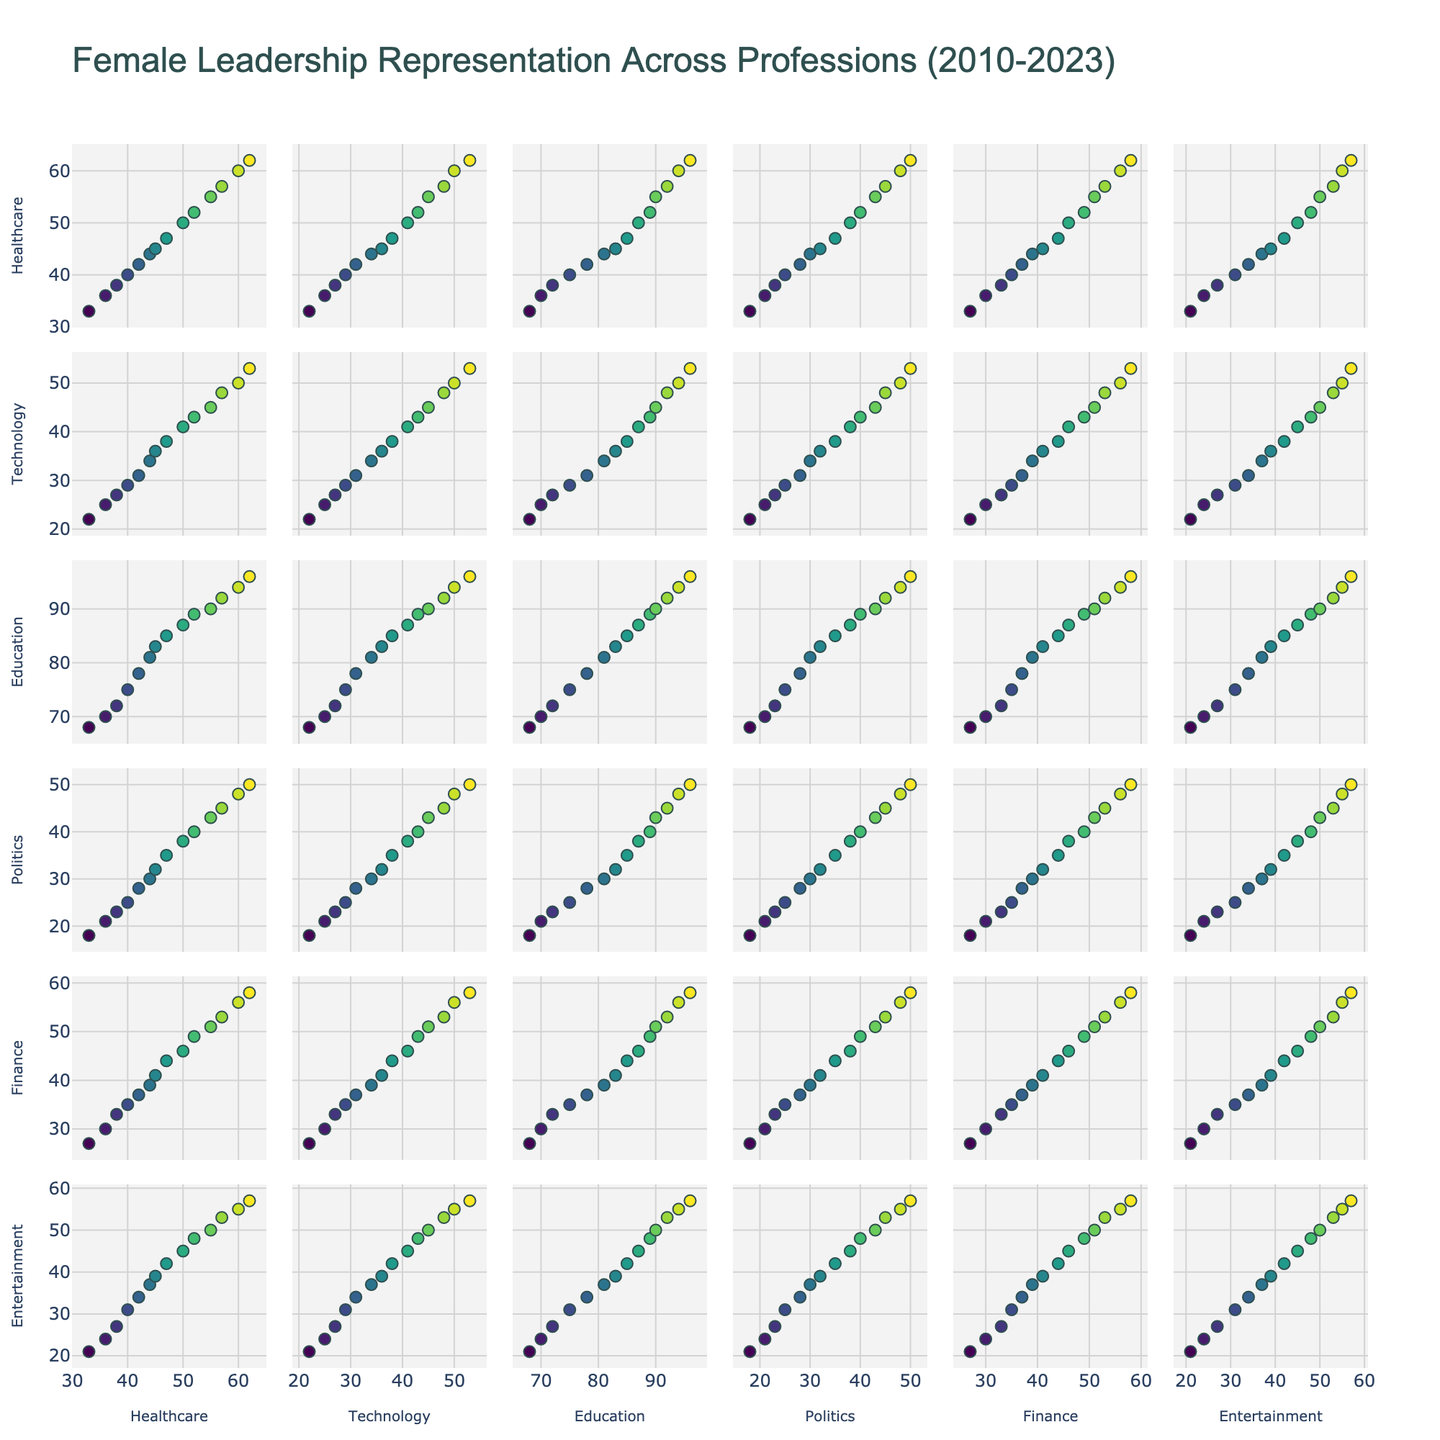What is the title of the figure? The title of the figure can be read directly from the top of the plot. It indicates what the scatter plot matrix is about.
Answer: Female Leadership Representation Across Professions (2010-2023) What are the professions represented along the axes of the plots? The scatter plot matrix has axes labeled with the various professions being analyzed. Each axis has the name of a profession.
Answer: Healthcare, Technology, Education, Politics, Finance, Entertainment Which profession shows the highest female leadership representation in 2023? By looking at the scatter plots where the data points for 2023 are located, we observe the plots with the highest values. The highest point on each axis will represent the female leadership percentage for that profession in 2023.
Answer: Education Comparing 2010 and 2020, which profession shows the largest increase in female leadership representation? First, identify the data points for 2010 and 2020 by hovering over them. Then, subtract the 2010 value from the 2020 value for each profession and determine which difference is the largest.
Answer: Education Which professions have a consistent increase in female leadership representation over the years? By analyzing the scatter plots, look for trends over time where data points show a steady increase. Professions where all the points form an upward trajectory indicate a consistent increase.
Answer: Healthcare, Technology, Education, Politics, Finance, Entertainment In 2023, compare the female leadership in Healthcare and Politics. Which is higher, and by how much? Locate the 2023 data points on the scatter plots for Healthcare and Politics. Compare their values and calculate the difference between them.
Answer: Healthcare is higher by 12 percentage points Is there a profession where female leadership grew faster during the first half of the decade (2010-2015) compared to the second half (2016-2023)? Calculate the difference in female leadership representation from 2010 to 2015 and from 2016 to 2023 for each profession. Compare these differences to identify which profession had a faster growth in the first half of the decade.
Answer: Technology Which two professions show the most similar trends in female leadership representation across the given years? By observing the scatter plots, identify the pairs of professions whose plots have data points that follow a similar upward trajectory closely to each other.
Answer: Healthcare and Technology What is the range of female leadership representation in Finance during the given years (2010-2023)? Identify the minimum and maximum values in the Finance scatter plot by looking at the lowest and highest data points.
Answer: 27% to 58% What is the average female leadership representation in Technology for the years 2010, 2015, and 2020? Find the values for 2010, 2015, and 2020 in the Technology plot. Sum these values and divide by 3 to obtain the average.
Answer: (22 + 34 + 45) / 3 = 33 